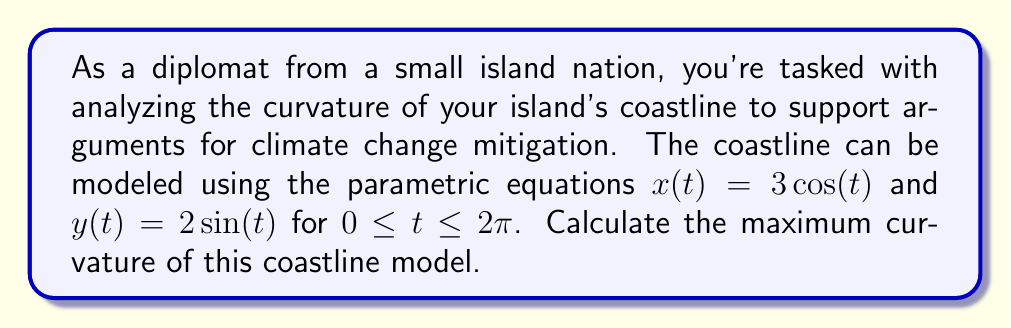Show me your answer to this math problem. To find the maximum curvature of the coastline, we'll follow these steps:

1) The curvature $\kappa$ of a curve given by parametric equations is:

   $$\kappa = \frac{|x'y'' - y'x''|}{(x'^2 + y'^2)^{3/2}}$$

2) Let's calculate the first and second derivatives:
   
   $x' = -3\sin(t)$, $y' = 2\cos(t)$
   $x'' = -3\cos(t)$, $y'' = -2\sin(t)$

3) Now, let's substitute these into the curvature formula:

   $$\kappa = \frac{|(-3\sin(t))(-2\sin(t)) - (2\cos(t))(-3\cos(t))|}{((-3\sin(t))^2 + (2\cos(t))^2)^{3/2}}$$

4) Simplify the numerator:

   $$\kappa = \frac{|6\sin^2(t) + 6\cos^2(t)|}{(9\sin^2(t) + 4\cos^2(t))^{3/2}}$$

5) The numerator simplifies to 6 (since $\sin^2(t) + \cos^2(t) = 1$):

   $$\kappa = \frac{6}{(9\sin^2(t) + 4\cos^2(t))^{3/2}}$$

6) To find the maximum curvature, we need to minimize the denominator. The denominator is minimized when $\sin^2(t) = 0$ and $\cos^2(t) = 1$, or vice versa.

7) The minimum value of the denominator is $4^{3/2} = 8$.

8) Therefore, the maximum curvature is:

   $$\kappa_{max} = \frac{6}{8} = \frac{3}{4}$$
Answer: The maximum curvature of the coastline model is $\frac{3}{4}$ or 0.75. 